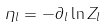<formula> <loc_0><loc_0><loc_500><loc_500>\eta _ { l } = - \partial _ { l } \ln Z _ { l }</formula> 